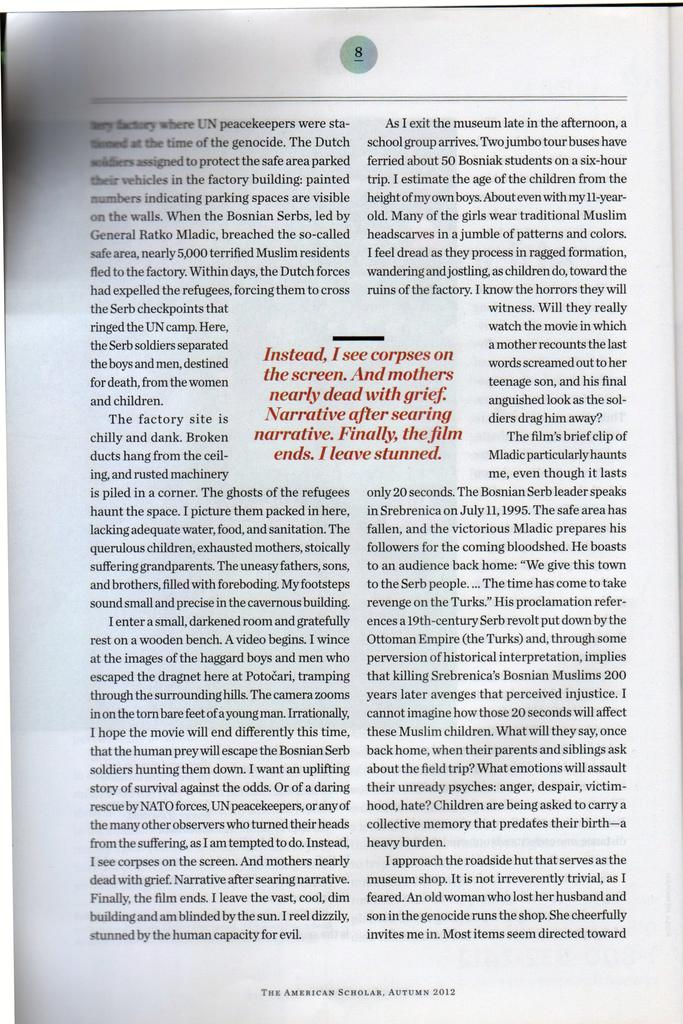What is present in the image that is related to writing or reading? There is a paper in the image. What can be said about the color of the paper? The paper is white in color. What is written or printed on the paper? The paper has information on it. Can you identify any specific detail about the information on the paper? Yes, the page number "8" is mentioned at the top of the information. What type of winter clothing is visible on the paper in the image? There is no winter clothing visible on the paper in the image; it contains information and the page number "8." 